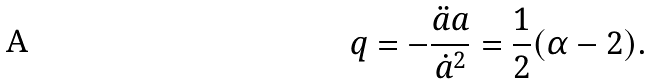Convert formula to latex. <formula><loc_0><loc_0><loc_500><loc_500>q = - \frac { \ddot { a } a } { { \dot { a } } ^ { 2 } } = \frac { 1 } { 2 } ( \alpha - 2 ) .</formula> 